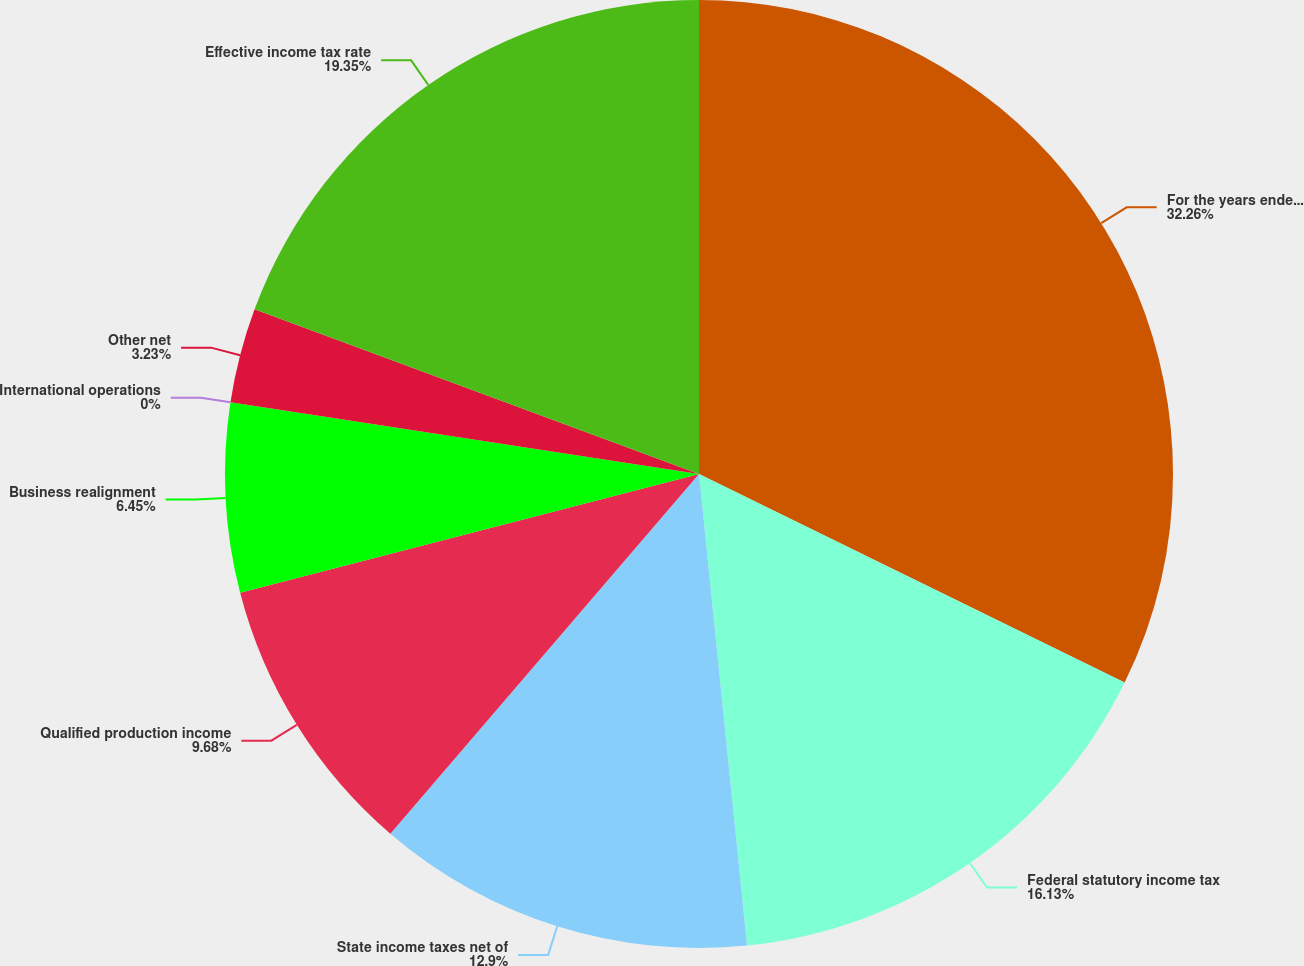<chart> <loc_0><loc_0><loc_500><loc_500><pie_chart><fcel>For the years ended December<fcel>Federal statutory income tax<fcel>State income taxes net of<fcel>Qualified production income<fcel>Business realignment<fcel>International operations<fcel>Other net<fcel>Effective income tax rate<nl><fcel>32.25%<fcel>16.13%<fcel>12.9%<fcel>9.68%<fcel>6.45%<fcel>0.0%<fcel>3.23%<fcel>19.35%<nl></chart> 